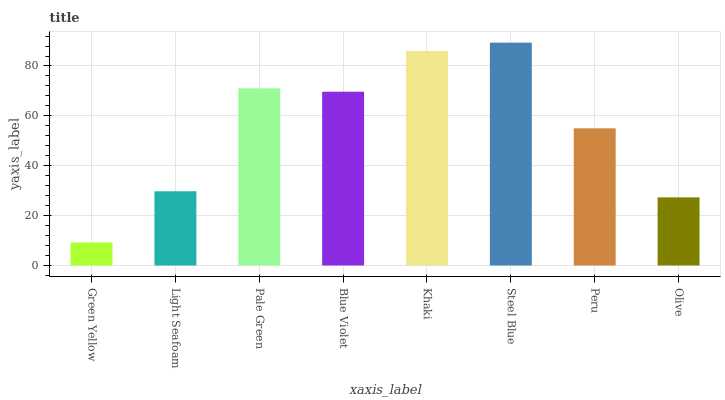Is Green Yellow the minimum?
Answer yes or no. Yes. Is Steel Blue the maximum?
Answer yes or no. Yes. Is Light Seafoam the minimum?
Answer yes or no. No. Is Light Seafoam the maximum?
Answer yes or no. No. Is Light Seafoam greater than Green Yellow?
Answer yes or no. Yes. Is Green Yellow less than Light Seafoam?
Answer yes or no. Yes. Is Green Yellow greater than Light Seafoam?
Answer yes or no. No. Is Light Seafoam less than Green Yellow?
Answer yes or no. No. Is Blue Violet the high median?
Answer yes or no. Yes. Is Peru the low median?
Answer yes or no. Yes. Is Steel Blue the high median?
Answer yes or no. No. Is Green Yellow the low median?
Answer yes or no. No. 